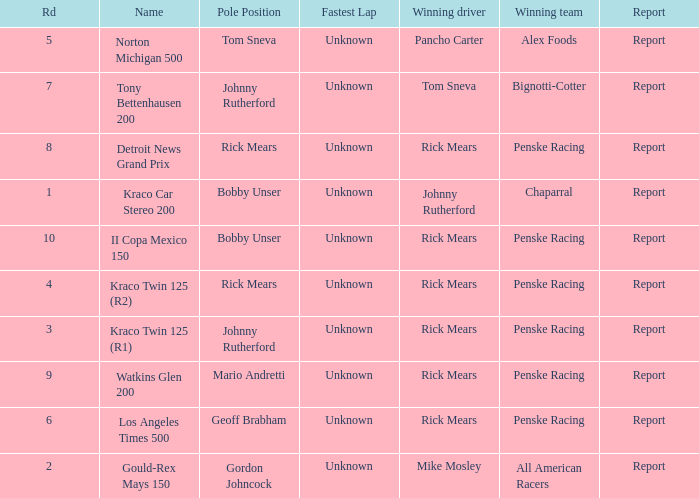What are the races that johnny rutherford has won? Kraco Car Stereo 200. 